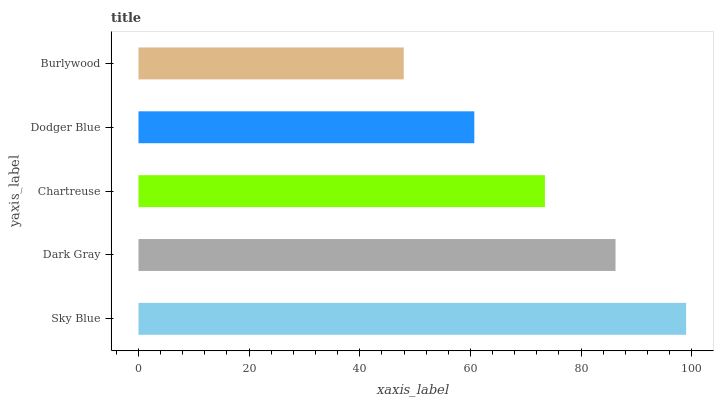Is Burlywood the minimum?
Answer yes or no. Yes. Is Sky Blue the maximum?
Answer yes or no. Yes. Is Dark Gray the minimum?
Answer yes or no. No. Is Dark Gray the maximum?
Answer yes or no. No. Is Sky Blue greater than Dark Gray?
Answer yes or no. Yes. Is Dark Gray less than Sky Blue?
Answer yes or no. Yes. Is Dark Gray greater than Sky Blue?
Answer yes or no. No. Is Sky Blue less than Dark Gray?
Answer yes or no. No. Is Chartreuse the high median?
Answer yes or no. Yes. Is Chartreuse the low median?
Answer yes or no. Yes. Is Sky Blue the high median?
Answer yes or no. No. Is Sky Blue the low median?
Answer yes or no. No. 